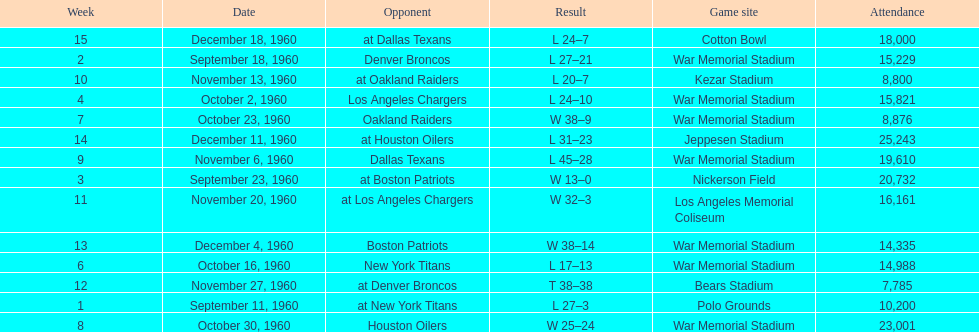How many times was war memorial stadium the game site? 6. 